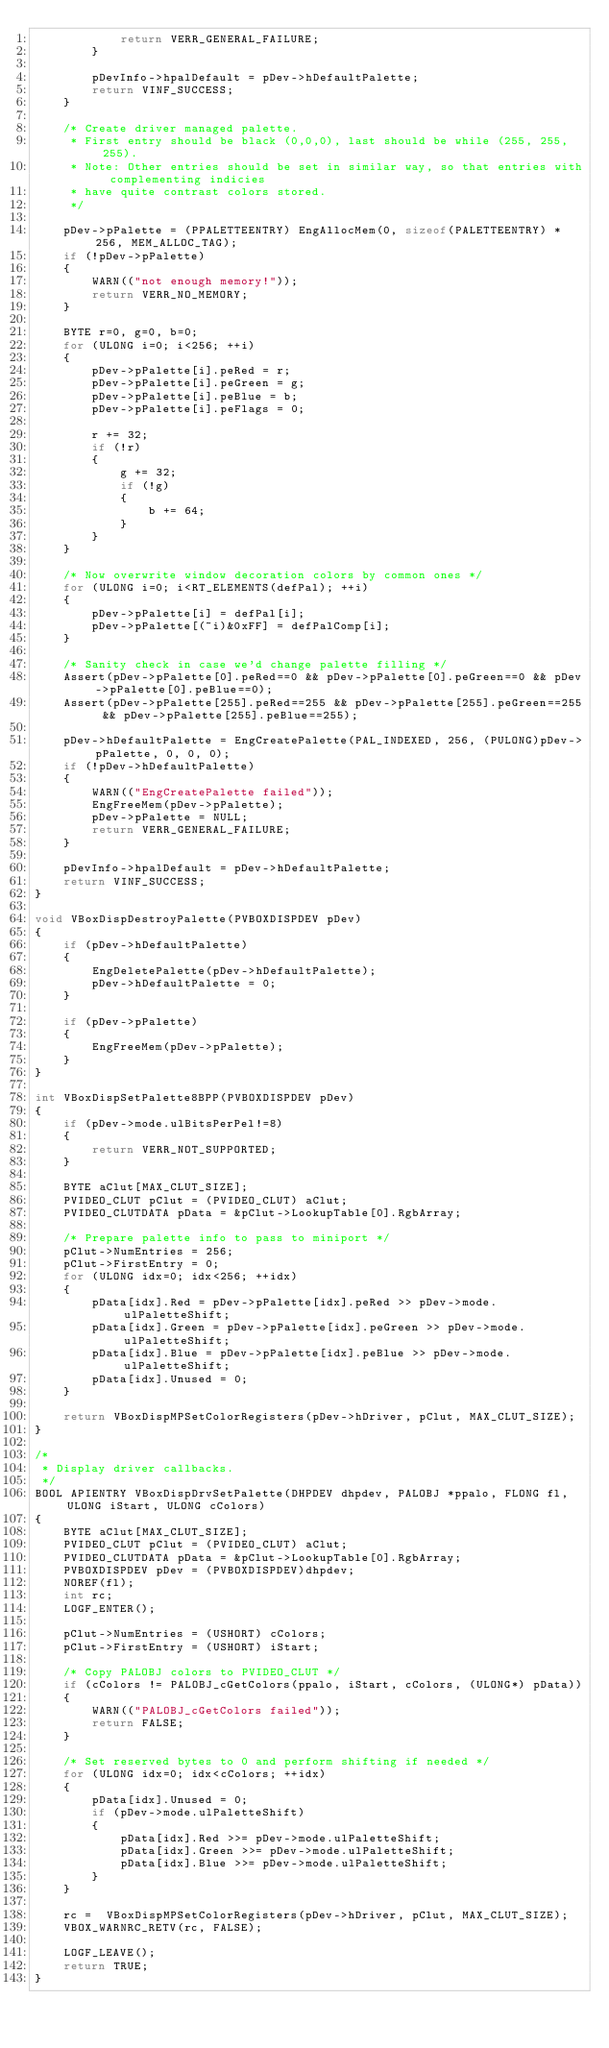<code> <loc_0><loc_0><loc_500><loc_500><_C++_>            return VERR_GENERAL_FAILURE;
        }

        pDevInfo->hpalDefault = pDev->hDefaultPalette;
        return VINF_SUCCESS;
    }

    /* Create driver managed palette.
     * First entry should be black (0,0,0), last should be while (255, 255, 255).
     * Note: Other entries should be set in similar way, so that entries with complementing indicies
     * have quite contrast colors stored.
     */

    pDev->pPalette = (PPALETTEENTRY) EngAllocMem(0, sizeof(PALETTEENTRY) * 256, MEM_ALLOC_TAG);
    if (!pDev->pPalette)
    {
        WARN(("not enough memory!"));
        return VERR_NO_MEMORY;
    }

    BYTE r=0, g=0, b=0;
    for (ULONG i=0; i<256; ++i)
    {
        pDev->pPalette[i].peRed = r;
        pDev->pPalette[i].peGreen = g;
        pDev->pPalette[i].peBlue = b;
        pDev->pPalette[i].peFlags = 0;

        r += 32;
        if (!r)
        {
            g += 32;
            if (!g)
            {
                b += 64;
            }
        }
    }

    /* Now overwrite window decoration colors by common ones */
    for (ULONG i=0; i<RT_ELEMENTS(defPal); ++i)
    {
        pDev->pPalette[i] = defPal[i];
        pDev->pPalette[(~i)&0xFF] = defPalComp[i];
    }

    /* Sanity check in case we'd change palette filling */
    Assert(pDev->pPalette[0].peRed==0 && pDev->pPalette[0].peGreen==0 && pDev->pPalette[0].peBlue==0);
    Assert(pDev->pPalette[255].peRed==255 && pDev->pPalette[255].peGreen==255 && pDev->pPalette[255].peBlue==255);

    pDev->hDefaultPalette = EngCreatePalette(PAL_INDEXED, 256, (PULONG)pDev->pPalette, 0, 0, 0);
    if (!pDev->hDefaultPalette)
    {
        WARN(("EngCreatePalette failed"));
        EngFreeMem(pDev->pPalette);
        pDev->pPalette = NULL;
        return VERR_GENERAL_FAILURE;
    }

    pDevInfo->hpalDefault = pDev->hDefaultPalette;
    return VINF_SUCCESS;
}

void VBoxDispDestroyPalette(PVBOXDISPDEV pDev)
{
    if (pDev->hDefaultPalette)
    {
        EngDeletePalette(pDev->hDefaultPalette);
        pDev->hDefaultPalette = 0;
    }

    if (pDev->pPalette)
    {
        EngFreeMem(pDev->pPalette);
    }
}

int VBoxDispSetPalette8BPP(PVBOXDISPDEV pDev)
{
    if (pDev->mode.ulBitsPerPel!=8)
    {
        return VERR_NOT_SUPPORTED;
    }

    BYTE aClut[MAX_CLUT_SIZE];
    PVIDEO_CLUT pClut = (PVIDEO_CLUT) aClut;
    PVIDEO_CLUTDATA pData = &pClut->LookupTable[0].RgbArray;

    /* Prepare palette info to pass to miniport */
    pClut->NumEntries = 256;
    pClut->FirstEntry = 0;
    for (ULONG idx=0; idx<256; ++idx)
    {
        pData[idx].Red = pDev->pPalette[idx].peRed >> pDev->mode.ulPaletteShift;
        pData[idx].Green = pDev->pPalette[idx].peGreen >> pDev->mode.ulPaletteShift;
        pData[idx].Blue = pDev->pPalette[idx].peBlue >> pDev->mode.ulPaletteShift;
        pData[idx].Unused = 0;
    }

    return VBoxDispMPSetColorRegisters(pDev->hDriver, pClut, MAX_CLUT_SIZE);
}

/*
 * Display driver callbacks.
 */
BOOL APIENTRY VBoxDispDrvSetPalette(DHPDEV dhpdev, PALOBJ *ppalo, FLONG fl, ULONG iStart, ULONG cColors)
{
    BYTE aClut[MAX_CLUT_SIZE];
    PVIDEO_CLUT pClut = (PVIDEO_CLUT) aClut;
    PVIDEO_CLUTDATA pData = &pClut->LookupTable[0].RgbArray;
    PVBOXDISPDEV pDev = (PVBOXDISPDEV)dhpdev;
    NOREF(fl);
    int rc;
    LOGF_ENTER();

    pClut->NumEntries = (USHORT) cColors;
    pClut->FirstEntry = (USHORT) iStart;

    /* Copy PALOBJ colors to PVIDEO_CLUT */
    if (cColors != PALOBJ_cGetColors(ppalo, iStart, cColors, (ULONG*) pData))
    {
        WARN(("PALOBJ_cGetColors failed"));
        return FALSE;
    }

    /* Set reserved bytes to 0 and perform shifting if needed */
    for (ULONG idx=0; idx<cColors; ++idx)
    {
        pData[idx].Unused = 0;
        if (pDev->mode.ulPaletteShift)
        {
            pData[idx].Red >>= pDev->mode.ulPaletteShift;
            pData[idx].Green >>= pDev->mode.ulPaletteShift;
            pData[idx].Blue >>= pDev->mode.ulPaletteShift;
        }
    }

    rc =  VBoxDispMPSetColorRegisters(pDev->hDriver, pClut, MAX_CLUT_SIZE);
    VBOX_WARNRC_RETV(rc, FALSE);

    LOGF_LEAVE();
    return TRUE;
}
</code> 